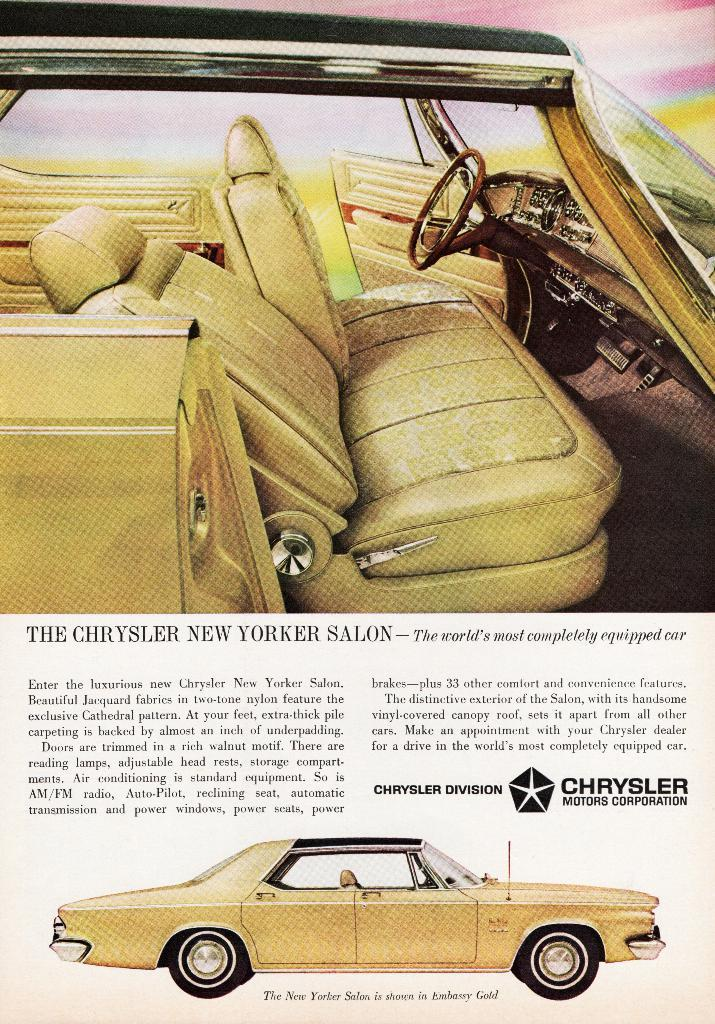What is present on the poster in the image? There is a poster in the image. What can be seen on the poster besides text? The poster contains images. What type of information is present on the poster? The poster contains text. What type of coil is visible in the image? There is no coil present in the image. What channel is the poster promoting in the image? The image does not contain any information about a specific channel. 